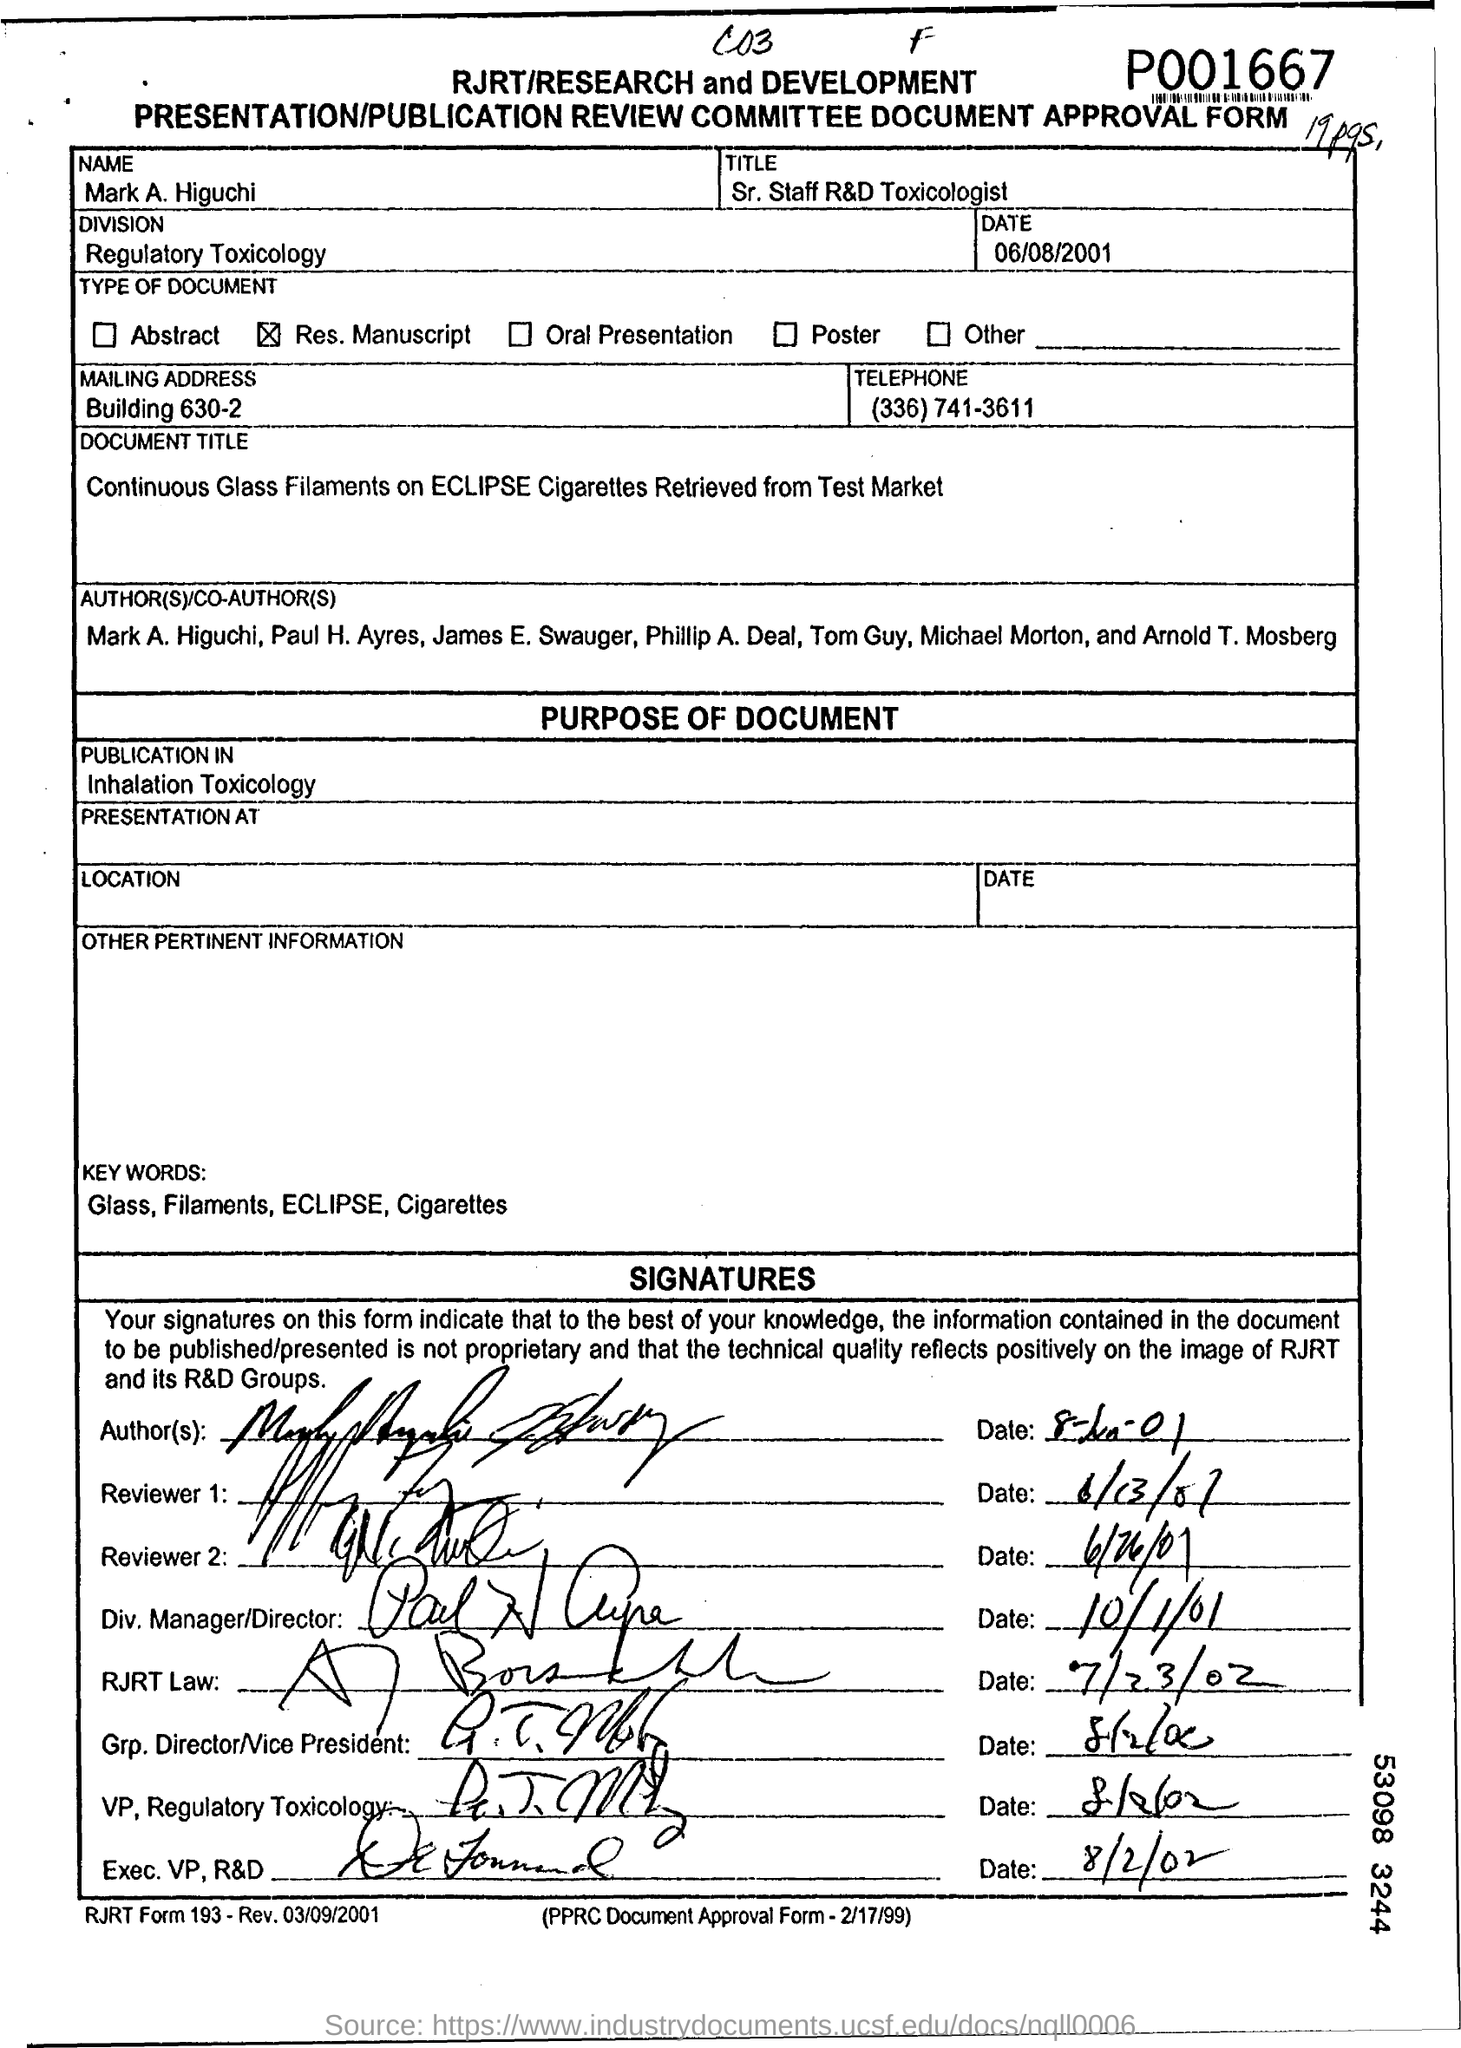Identify some key points in this picture. Mr. Mark A. Higuchi is a Senior Staff R&D Toxicologist. Mark A. Higuchi is a member of the Regulatory Toxicology division. The mailing address of Mark A. Higuchi is Building 630-2. 